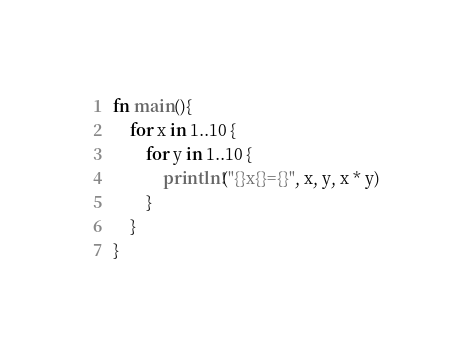Convert code to text. <code><loc_0><loc_0><loc_500><loc_500><_Rust_>fn main(){
    for x in 1..10 {
        for y in 1..10 {
            println!("{}x{}={}", x, y, x * y)
        }
    }
}
</code> 